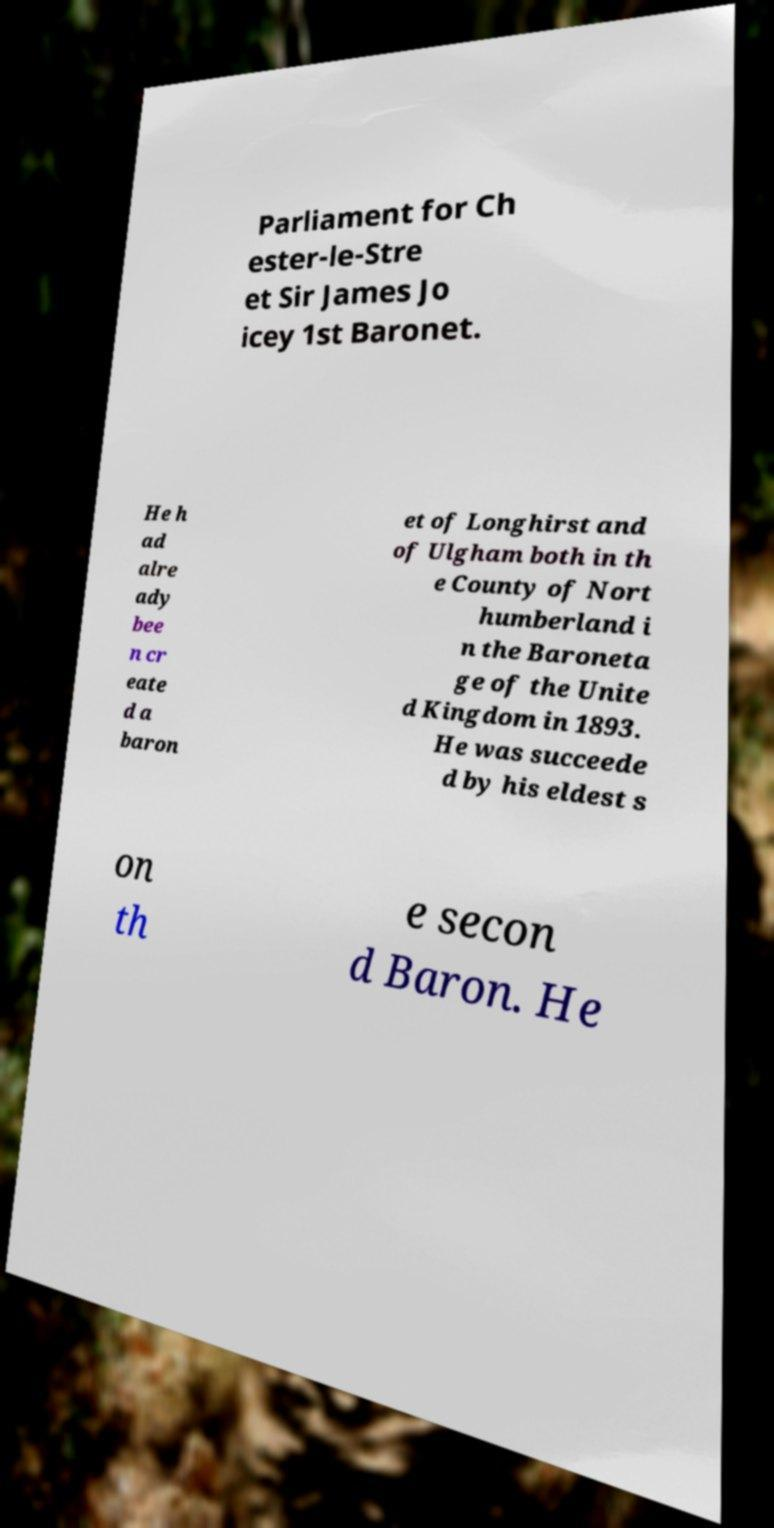Can you accurately transcribe the text from the provided image for me? Parliament for Ch ester-le-Stre et Sir James Jo icey 1st Baronet. He h ad alre ady bee n cr eate d a baron et of Longhirst and of Ulgham both in th e County of Nort humberland i n the Baroneta ge of the Unite d Kingdom in 1893. He was succeede d by his eldest s on th e secon d Baron. He 